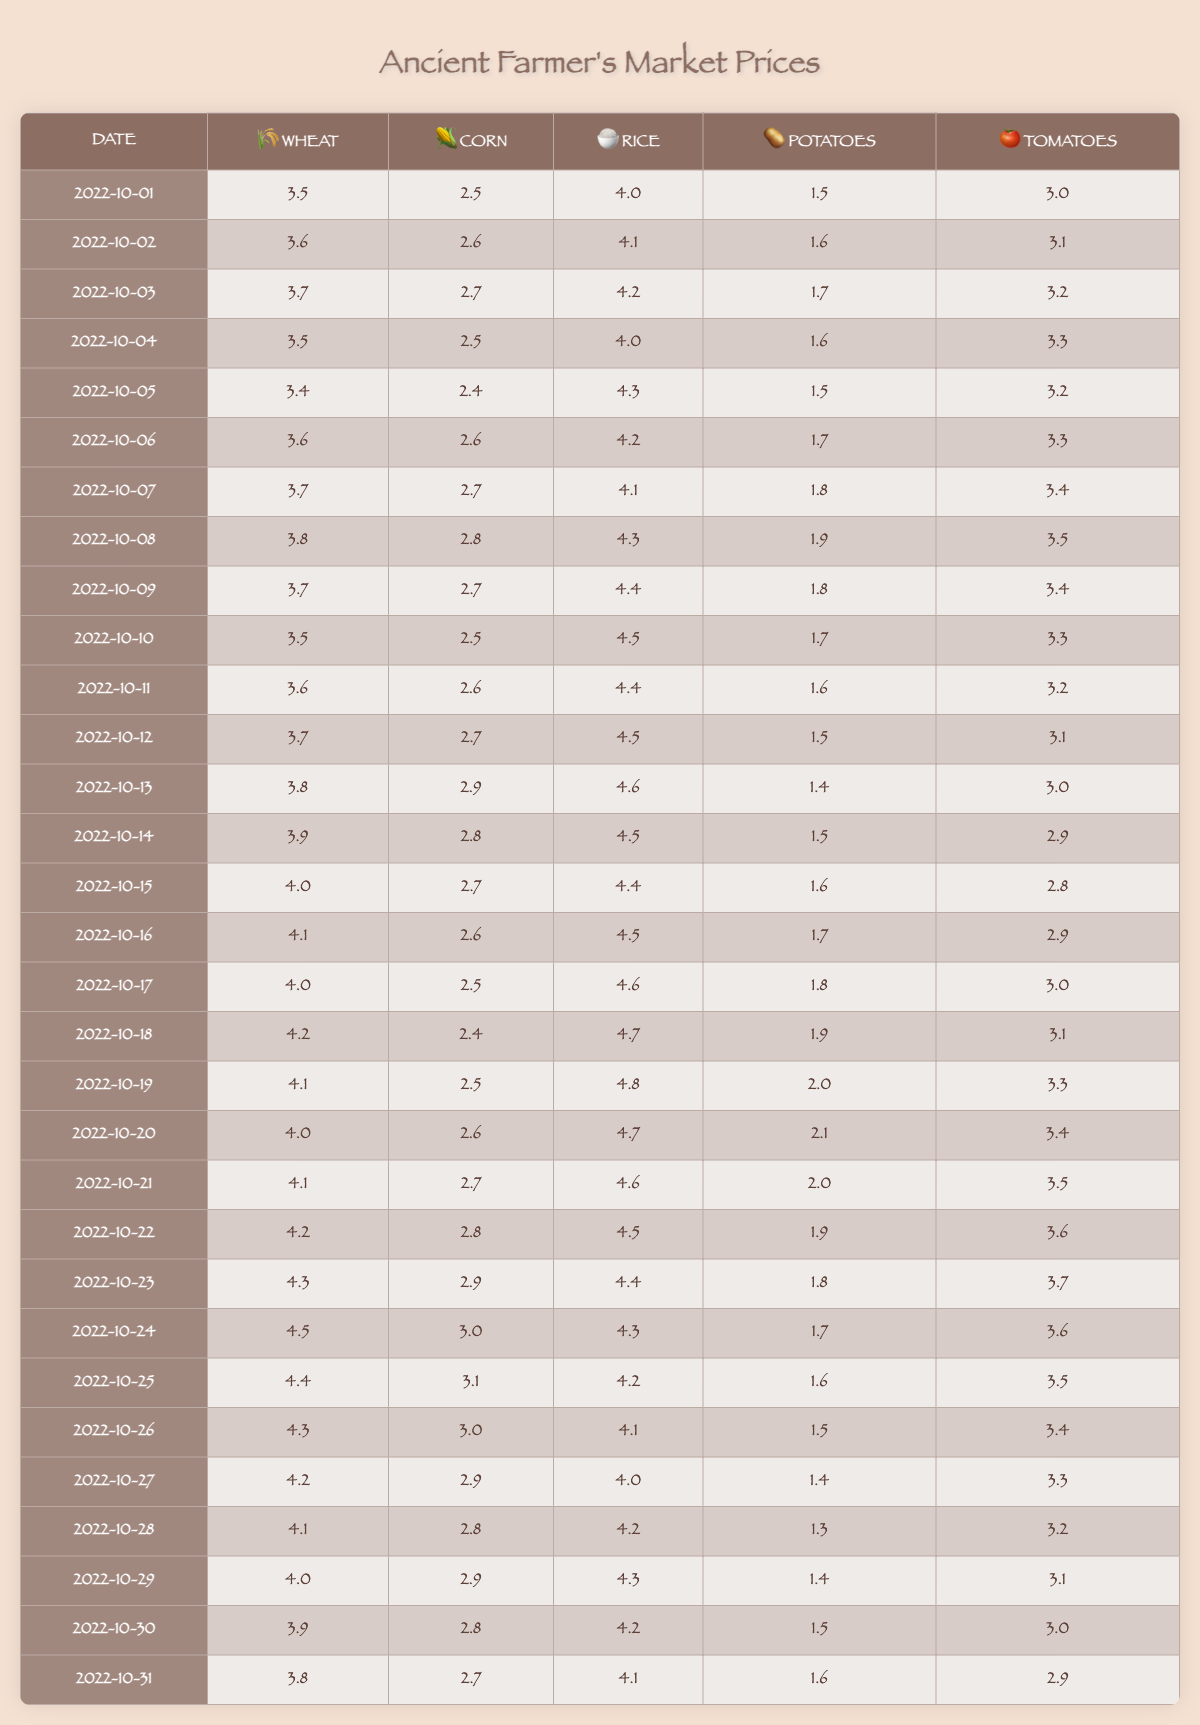What was the highest market price for Wheat during October 2022? The highest price is found by checking all the Wheat prices listed for each date. Scanning through, the maximum is 4.5 on October 24.
Answer: 4.5 What was the price of Corn on October 10, 2022? The table lists Corn's price for each date. Specifically, on October 10, it is 2.5.
Answer: 2.5 What is the average price of Rice during October 2022? To find the average, sum all the Rice prices for the month (4.0 + 4.1 + 4.2 + ... + 4.1) for the 31 days, which totals to 130.1. There are 31 days, so the average is 130.1/31 ≈ 4.2.
Answer: ≈ 4.2 What was the market price trend for Potatoes during October 2022? Looking at the Potatoes prices from the first to the last day of October, they start at 1.5 and fluctuate, reaching a peak of 2.1 on October 20, before tapering back down to 1.6 on October 31. This indicates an overall upward then downward trend.
Answer: Upward then downward Did the price of Tomatoes ever drop below 3.0 in October 2022? By reviewing the prices in the table, it shows that from October 1 to 5, the prices were above 3.0, but from October 13 onwards, it dropped below 3.0 on the 14th and stayed below 3.0 until the end of the month.
Answer: Yes What is the total price difference between Wheat and Corn on October 15, 2022? On October 15, Wheat is priced at 4.0 while Corn is at 2.7. The price difference is calculated as 4.0 - 2.7 = 1.3, indicating Wheat is 1.3 more expensive than Corn.
Answer: 1.3 Which crop had the highest average price during October 2022? To determine the highest average, calculate the average for each crop: Wheat ≈ 4.0, Corn ≈ 2.7, Rice ≈ 4.2, Potatoes ≈ 1.7, and Tomatoes ≈ 3.3. The highest average price is for Rice, which is 4.2.
Answer: Rice What are the price changes in Tomatoes between October 25 and October 31? On October 25, the price of Tomatoes is 3.5 and it changes to 2.9 on October 31. The change is calculated as 2.9 - 3.5 = -0.6, indicating a decrease of 0.6.
Answer: -0.6 Was the price of Corn consistent throughout October 2022? Consistency means that the price does not vary significantly. By checking the prices, they fluctuate between 2.4 to 3.1, showing considerable variation, especially from October 5 to 20.
Answer: No What is the total price of all crops on October 20, 2022? To find this total, add the prices for all crops on this date: 4.0 (Wheat) + 2.6 (Corn) + 4.7 (Rice) + 2.1 (Potatoes) + 3.4 (Tomatoes) = 16.8.
Answer: 16.8 In which week did Rice have the highest price, and what was that price? Scanning through the Rice prices week by week, the highest price is 4.8, which occurred on October 19. This is in the third week of October.
Answer: 4.8, third week 